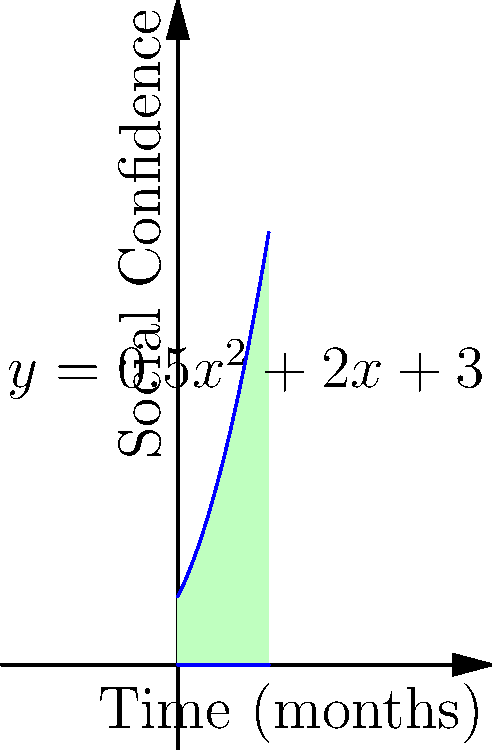A life coach is tracking a client's progress in overcoming social anxiety. The client's social confidence over time can be modeled by the function $f(x) = 0.5x^2 + 2x + 3$, where $x$ represents the number of months since starting therapy and $f(x)$ represents the client's confidence level. Calculate the total improvement in social confidence over the first 4 months of therapy by finding the area under the curve from $x=0$ to $x=4$. To find the area under the curve, we need to integrate the function $f(x) = 0.5x^2 + 2x + 3$ from $x=0$ to $x=4$. Here's how we do it:

1) Set up the definite integral:
   $$\int_0^4 (0.5x^2 + 2x + 3) dx$$

2) Integrate each term:
   $$\left[\frac{1}{3}(0.5x^3) + x^2 + 3x\right]_0^4$$

3) Evaluate the integral at the upper and lower bounds:
   $$\left(\frac{1}{3}(0.5(4^3)) + 4^2 + 3(4)\right) - \left(\frac{1}{3}(0.5(0^3)) + 0^2 + 3(0)\right)$$

4) Simplify:
   $$(10.67 + 16 + 12) - (0 + 0 + 0) = 38.67$$

Therefore, the total improvement in social confidence over the first 4 months is 38.67 units.
Answer: 38.67 units 